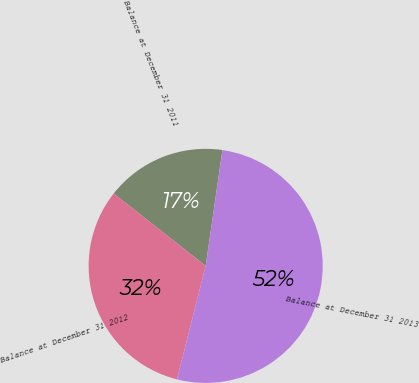Convert chart. <chart><loc_0><loc_0><loc_500><loc_500><pie_chart><fcel>Balance at December 31 2011<fcel>Balance at December 31 2012<fcel>Balance at December 31 2013<nl><fcel>16.67%<fcel>31.67%<fcel>51.67%<nl></chart> 